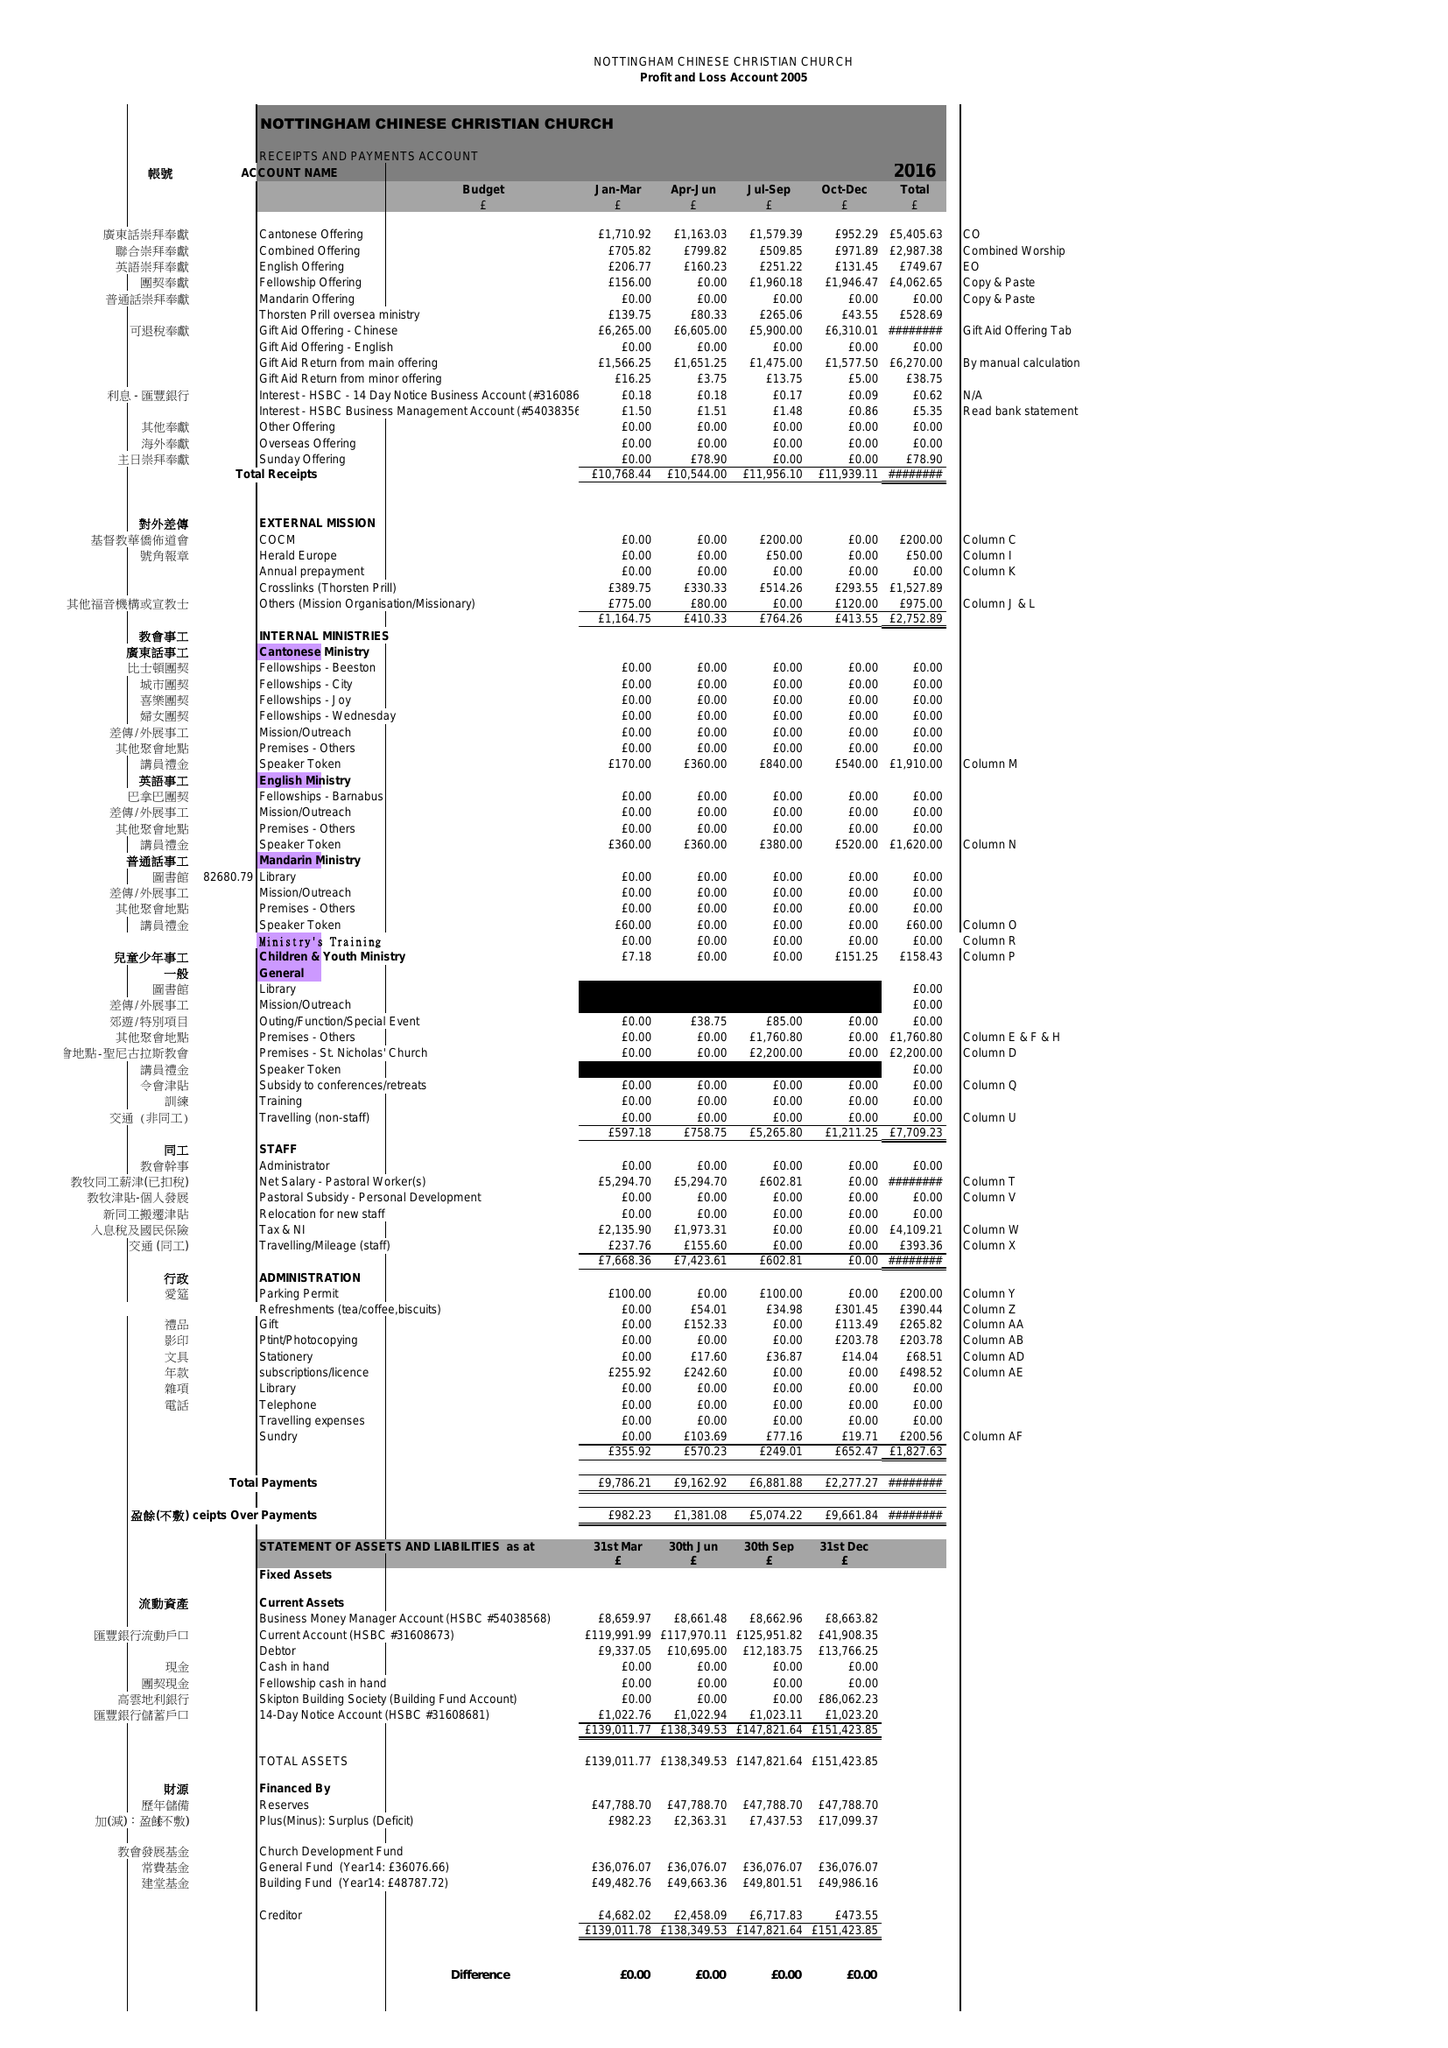What is the value for the report_date?
Answer the question using a single word or phrase. 2016-12-31 